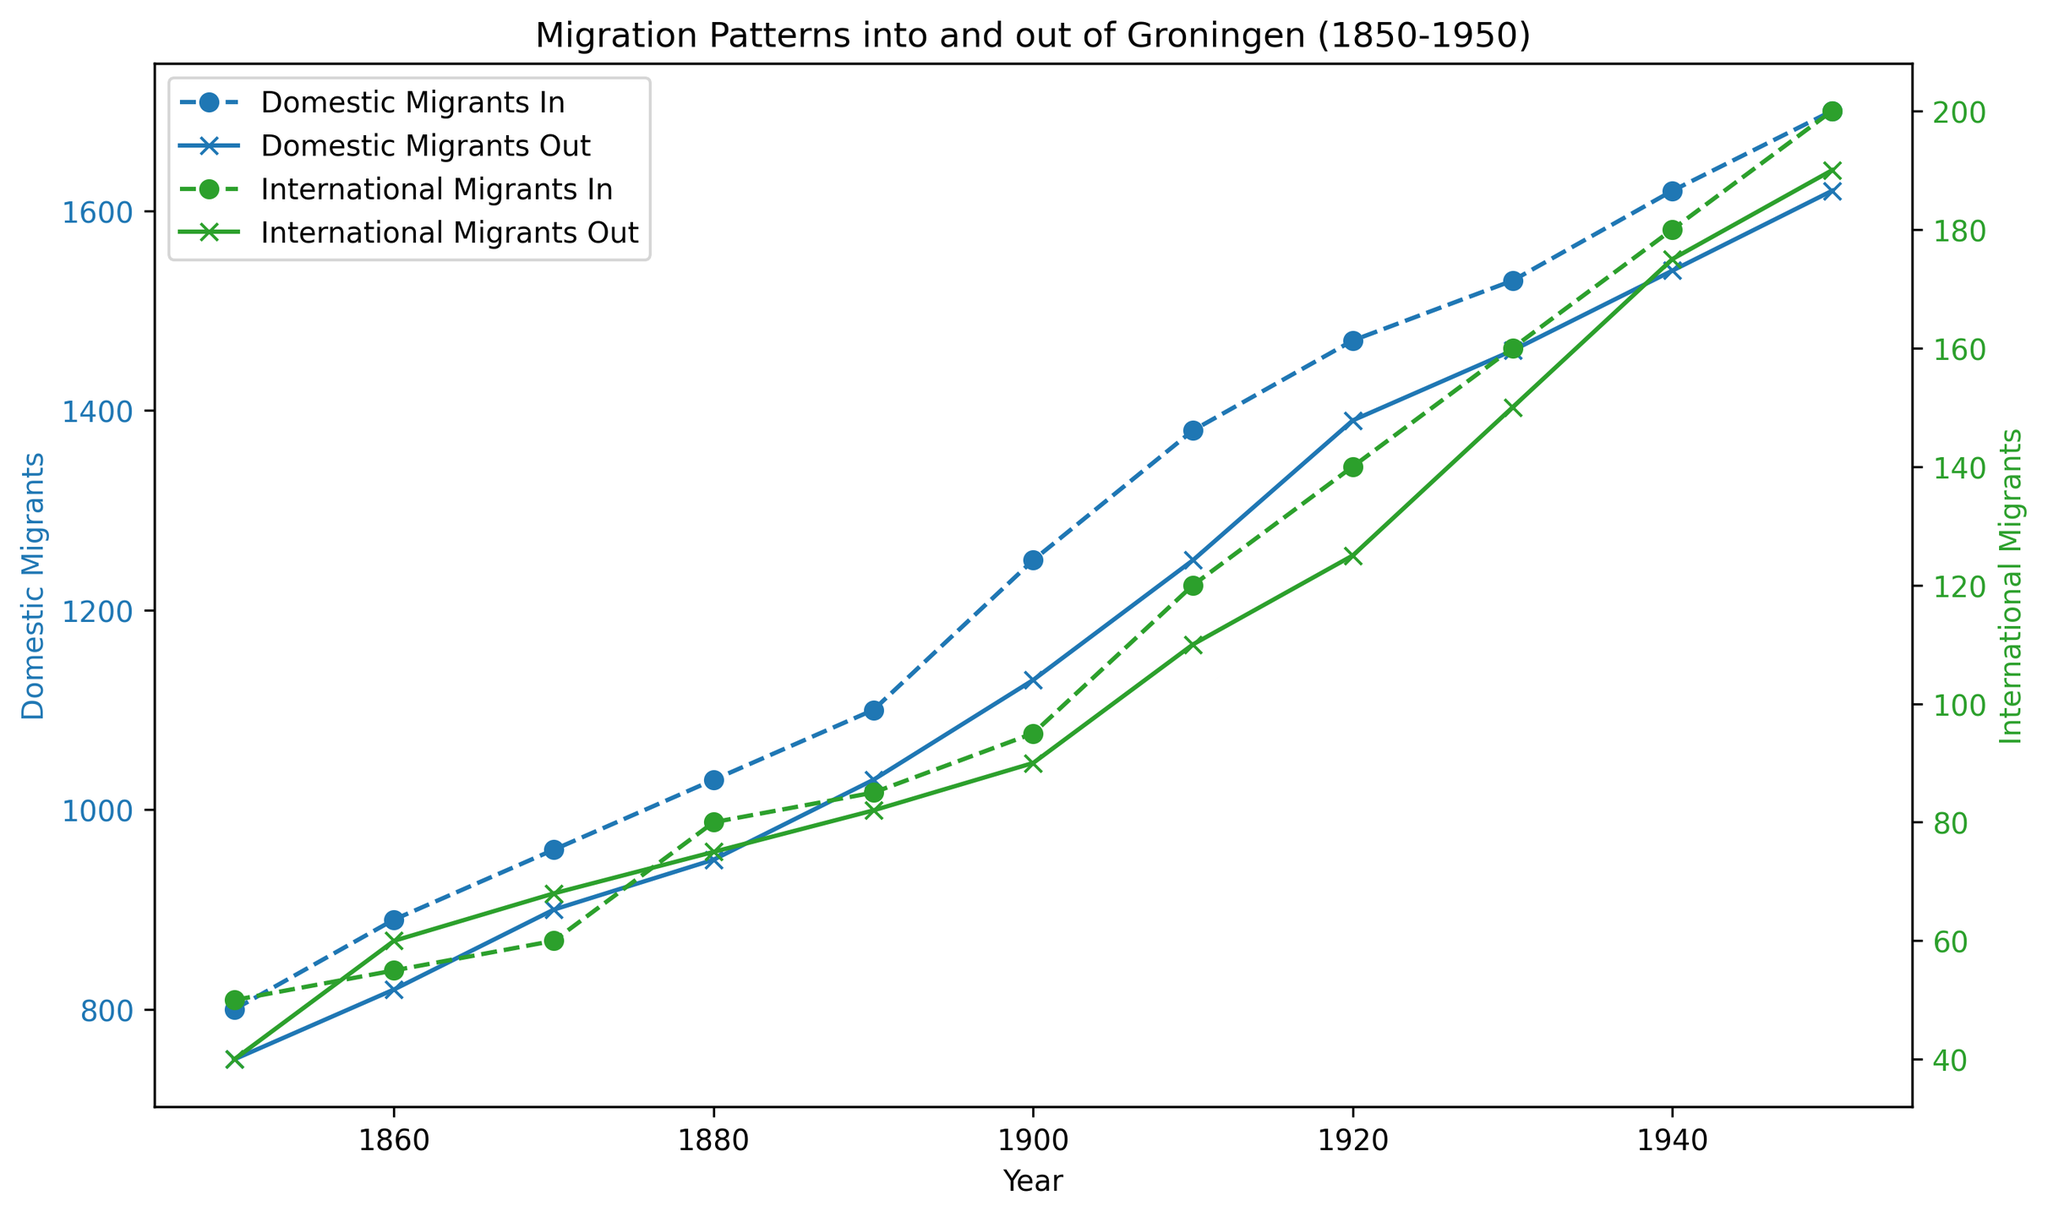Which year has the highest number of domestic migrants moving into Groningen? To determine the year with the highest number of domestic migrants coming into Groningen, look at the peaks in the blue dotted line (Domestic Migrants In). The highest peak is in the year 1950.
Answer: 1950 How has the pattern of international migrants moving out of Groningen changed over the years? Observing the green solid line (International Migrants Out), we see that the numbers gradually increase over time, starting from 40 in 1850 and peaking at 190 in 1950. This indicates a trend of increasing international migration out of Groningen over the 100-year period.
Answer: Increased over time What is the difference in the number of domestic migrants moving in and out in 1910? To find the difference, compare the values for Domestic Migrants In and Out in 1910. Domestic Migrants In is 1380, and Domestic Migrants Out is 1250. Difference = 1380 - 1250 = 130.
Answer: 130 Between which decades did the number of international migrants moving into Groningen increase the most? Look at the green dotted line (International Migrants In) and compare the increases over each decade. The largest increase occurs between 1940 (180) and 1950 (200), which is a change of 20.
Answer: 1940-1950 By how much did the domestic out-migration increase from 1850 to 1950? The number of Domestic Migrants Out in 1850 is 750, and in 1950 it is 1620. To find the increase: 1620 - 750 = 870.
Answer: 870 In which year did the number of international migrants moving out equal the number moving in? Identify where the green "x" line (International Migrants Out) intersects with the green dotted line (International Migrants In), which occurs in 1860, with both having around 55-60 migrants.
Answer: 1860 What notable trend is seen in the domestic migration patterns between 1880 and 1920? By observing the blue lines (both dotted and solid) between 1880 to 1920, a consistent and steady increase is apparent, indicating growing domestic migration flows during these years.
Answer: Steady increase Which migration type showed more fluctuation over the years, domestic or international? Compare the blue lines (Domestic In and Out) with the green lines (International In and Out). The green lines show relatively more fluctuation with bigger relative increases and decreases compared to the smoother blue lines.
Answer: International What was the combined total number of all types of migrants into Groningen in 1900? Sum the values of Domestic Migrants In and International Migrants In for 1900. Domestic Migrants In: 1250, International Migrants In: 95, Combined Total: 1250 + 95 = 1345.
Answer: 1345 